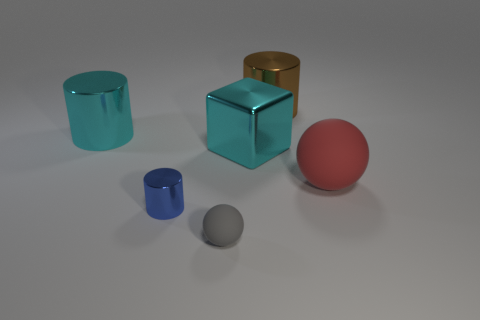Subtract all small blue shiny cylinders. How many cylinders are left? 2 Subtract 2 cylinders. How many cylinders are left? 1 Subtract all green cubes. Subtract all gray balls. How many cubes are left? 1 Subtract all purple balls. How many red cylinders are left? 0 Subtract all large cubes. Subtract all big red rubber things. How many objects are left? 4 Add 2 big red rubber spheres. How many big red rubber spheres are left? 3 Add 1 things. How many things exist? 7 Add 1 large cyan cylinders. How many objects exist? 7 Subtract all brown cylinders. How many cylinders are left? 2 Subtract 0 brown balls. How many objects are left? 6 